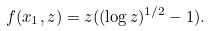Convert formula to latex. <formula><loc_0><loc_0><loc_500><loc_500>f ( x _ { 1 } , z ) = z ( ( \log z ) ^ { 1 / 2 } - 1 ) .</formula> 